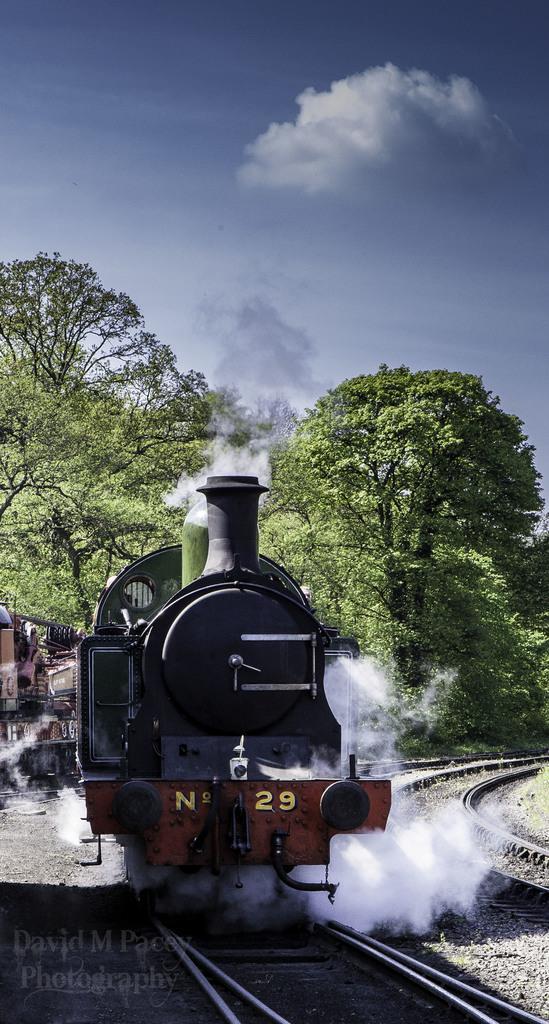In one or two sentences, can you explain what this image depicts? In this image in front there is a train on the railway track. In the background of the image there are trees and sky. There is some text at the bottom of the image. 